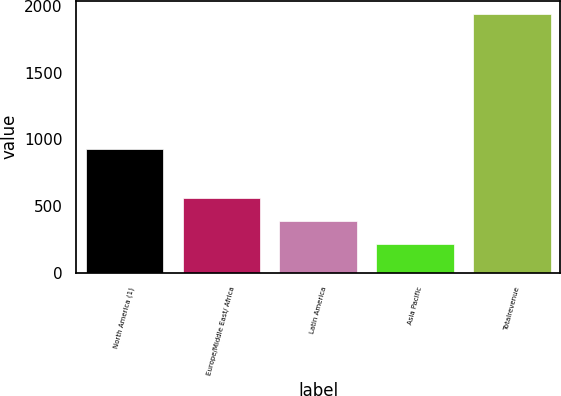Convert chart to OTSL. <chart><loc_0><loc_0><loc_500><loc_500><bar_chart><fcel>North America (1)<fcel>Europe/Middle East/ Africa<fcel>Latin America<fcel>Asia Pacific<fcel>Totalrevenue<nl><fcel>926.8<fcel>562.6<fcel>390.05<fcel>217.5<fcel>1943<nl></chart> 